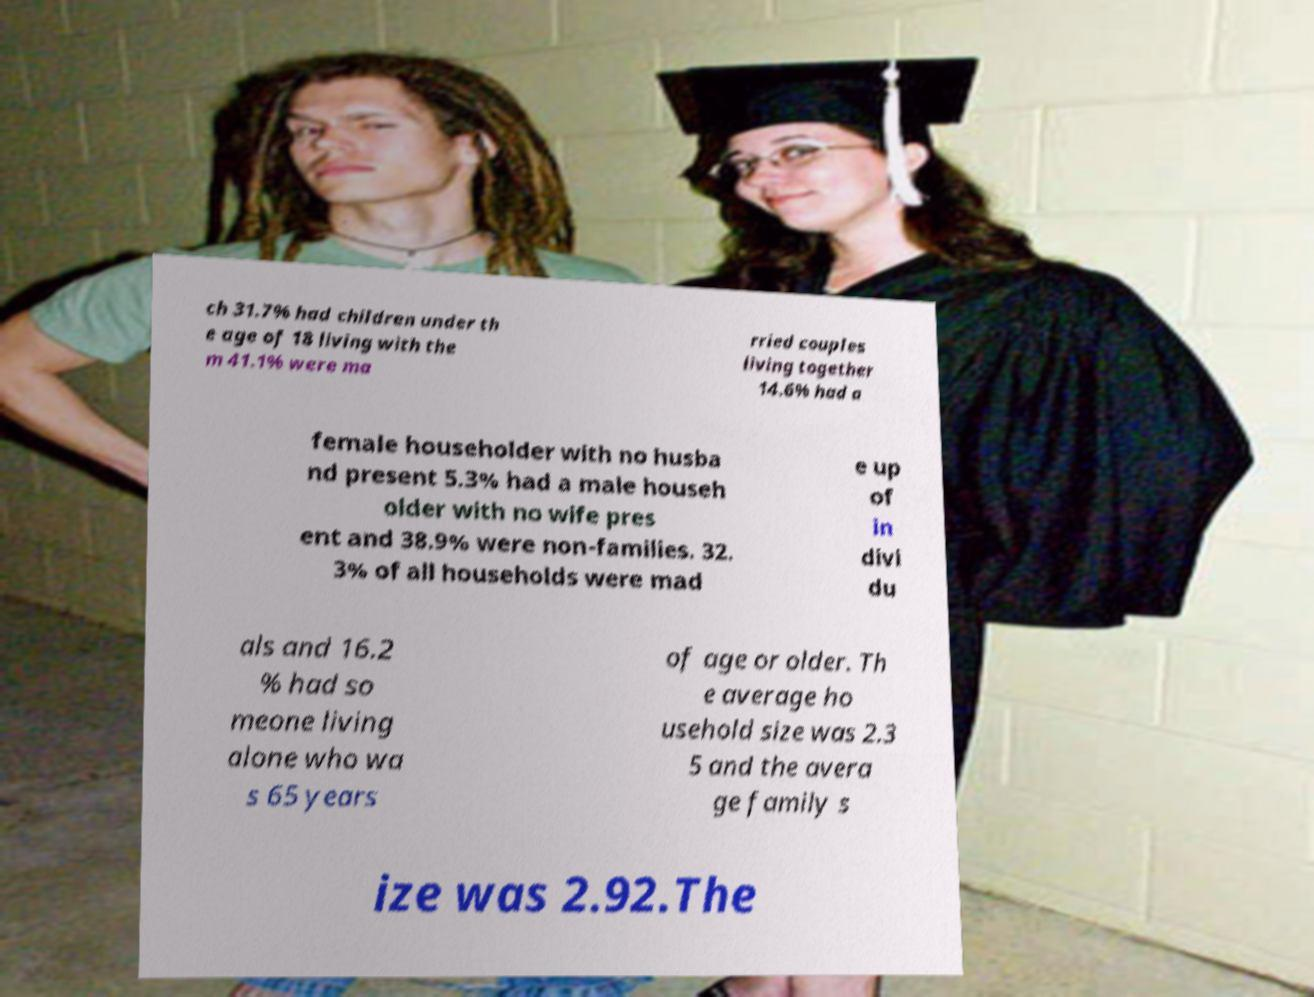Can you read and provide the text displayed in the image?This photo seems to have some interesting text. Can you extract and type it out for me? ch 31.7% had children under th e age of 18 living with the m 41.1% were ma rried couples living together 14.6% had a female householder with no husba nd present 5.3% had a male househ older with no wife pres ent and 38.9% were non-families. 32. 3% of all households were mad e up of in divi du als and 16.2 % had so meone living alone who wa s 65 years of age or older. Th e average ho usehold size was 2.3 5 and the avera ge family s ize was 2.92.The 